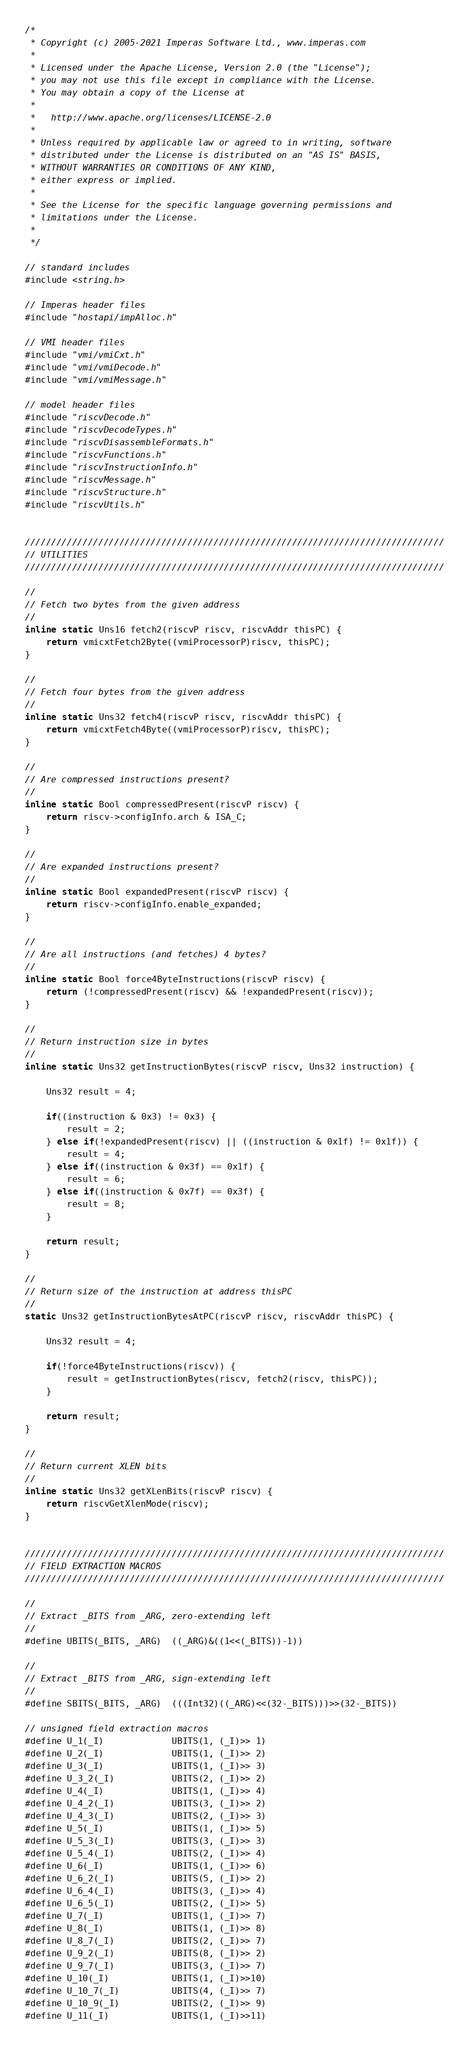Convert code to text. <code><loc_0><loc_0><loc_500><loc_500><_C_>/*
 * Copyright (c) 2005-2021 Imperas Software Ltd., www.imperas.com
 *
 * Licensed under the Apache License, Version 2.0 (the "License");
 * you may not use this file except in compliance with the License.
 * You may obtain a copy of the License at
 *
 *   http://www.apache.org/licenses/LICENSE-2.0
 *
 * Unless required by applicable law or agreed to in writing, software
 * distributed under the License is distributed on an "AS IS" BASIS,
 * WITHOUT WARRANTIES OR CONDITIONS OF ANY KIND,
 * either express or implied.
 *
 * See the License for the specific language governing permissions and
 * limitations under the License.
 *
 */

// standard includes
#include <string.h>

// Imperas header files
#include "hostapi/impAlloc.h"

// VMI header files
#include "vmi/vmiCxt.h"
#include "vmi/vmiDecode.h"
#include "vmi/vmiMessage.h"

// model header files
#include "riscvDecode.h"
#include "riscvDecodeTypes.h"
#include "riscvDisassembleFormats.h"
#include "riscvFunctions.h"
#include "riscvInstructionInfo.h"
#include "riscvMessage.h"
#include "riscvStructure.h"
#include "riscvUtils.h"


////////////////////////////////////////////////////////////////////////////////
// UTILITIES
////////////////////////////////////////////////////////////////////////////////

//
// Fetch two bytes from the given address
//
inline static Uns16 fetch2(riscvP riscv, riscvAddr thisPC) {
    return vmicxtFetch2Byte((vmiProcessorP)riscv, thisPC);
}

//
// Fetch four bytes from the given address
//
inline static Uns32 fetch4(riscvP riscv, riscvAddr thisPC) {
    return vmicxtFetch4Byte((vmiProcessorP)riscv, thisPC);
}

//
// Are compressed instructions present?
//
inline static Bool compressedPresent(riscvP riscv) {
    return riscv->configInfo.arch & ISA_C;
}

//
// Are expanded instructions present?
//
inline static Bool expandedPresent(riscvP riscv) {
    return riscv->configInfo.enable_expanded;
}

//
// Are all instructions (and fetches) 4 bytes?
//
inline static Bool force4ByteInstructions(riscvP riscv) {
    return (!compressedPresent(riscv) && !expandedPresent(riscv));
}

//
// Return instruction size in bytes
//
inline static Uns32 getInstructionBytes(riscvP riscv, Uns32 instruction) {

    Uns32 result = 4;

    if((instruction & 0x3) != 0x3) {
        result = 2;
    } else if(!expandedPresent(riscv) || ((instruction & 0x1f) != 0x1f)) {
        result = 4;
    } else if((instruction & 0x3f) == 0x1f) {
        result = 6;
    } else if((instruction & 0x7f) == 0x3f) {
        result = 8;
    }

    return result;
}

//
// Return size of the instruction at address thisPC
//
static Uns32 getInstructionBytesAtPC(riscvP riscv, riscvAddr thisPC) {

    Uns32 result = 4;

    if(!force4ByteInstructions(riscv)) {
        result = getInstructionBytes(riscv, fetch2(riscv, thisPC));
    }

    return result;
}

//
// Return current XLEN bits
//
inline static Uns32 getXLenBits(riscvP riscv) {
    return riscvGetXlenMode(riscv);
}


////////////////////////////////////////////////////////////////////////////////
// FIELD EXTRACTION MACROS
////////////////////////////////////////////////////////////////////////////////

//
// Extract _BITS from _ARG, zero-extending left
//
#define UBITS(_BITS, _ARG)  ((_ARG)&((1<<(_BITS))-1))

//
// Extract _BITS from _ARG, sign-extending left
//
#define SBITS(_BITS, _ARG)  (((Int32)((_ARG)<<(32-_BITS)))>>(32-_BITS))

// unsigned field extraction macros
#define U_1(_I)             UBITS(1, (_I)>> 1)
#define U_2(_I)             UBITS(1, (_I)>> 2)
#define U_3(_I)             UBITS(1, (_I)>> 3)
#define U_3_2(_I)           UBITS(2, (_I)>> 2)
#define U_4(_I)             UBITS(1, (_I)>> 4)
#define U_4_2(_I)           UBITS(3, (_I)>> 2)
#define U_4_3(_I)           UBITS(2, (_I)>> 3)
#define U_5(_I)             UBITS(1, (_I)>> 5)
#define U_5_3(_I)           UBITS(3, (_I)>> 3)
#define U_5_4(_I)           UBITS(2, (_I)>> 4)
#define U_6(_I)             UBITS(1, (_I)>> 6)
#define U_6_2(_I)           UBITS(5, (_I)>> 2)
#define U_6_4(_I)           UBITS(3, (_I)>> 4)
#define U_6_5(_I)           UBITS(2, (_I)>> 5)
#define U_7(_I)             UBITS(1, (_I)>> 7)
#define U_8(_I)             UBITS(1, (_I)>> 8)
#define U_8_7(_I)           UBITS(2, (_I)>> 7)
#define U_9_2(_I)           UBITS(8, (_I)>> 2)
#define U_9_7(_I)           UBITS(3, (_I)>> 7)
#define U_10(_I)            UBITS(1, (_I)>>10)
#define U_10_7(_I)          UBITS(4, (_I)>> 7)
#define U_10_9(_I)          UBITS(2, (_I)>> 9)
#define U_11(_I)            UBITS(1, (_I)>>11)</code> 